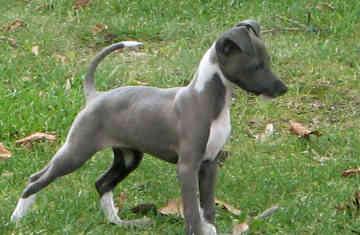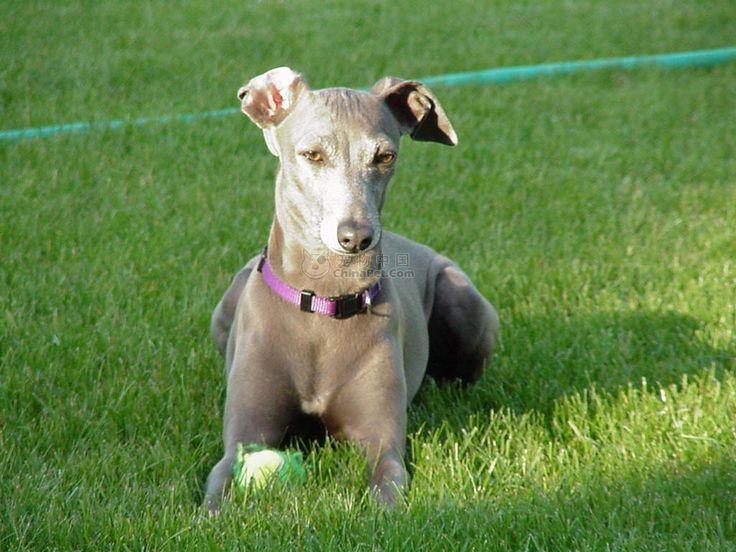The first image is the image on the left, the second image is the image on the right. Evaluate the accuracy of this statement regarding the images: "The combined images include two dogs in motion, and no images show a human with a dog.". Is it true? Answer yes or no. No. The first image is the image on the left, the second image is the image on the right. Considering the images on both sides, is "There are at least three mammals in total." valid? Answer yes or no. No. 